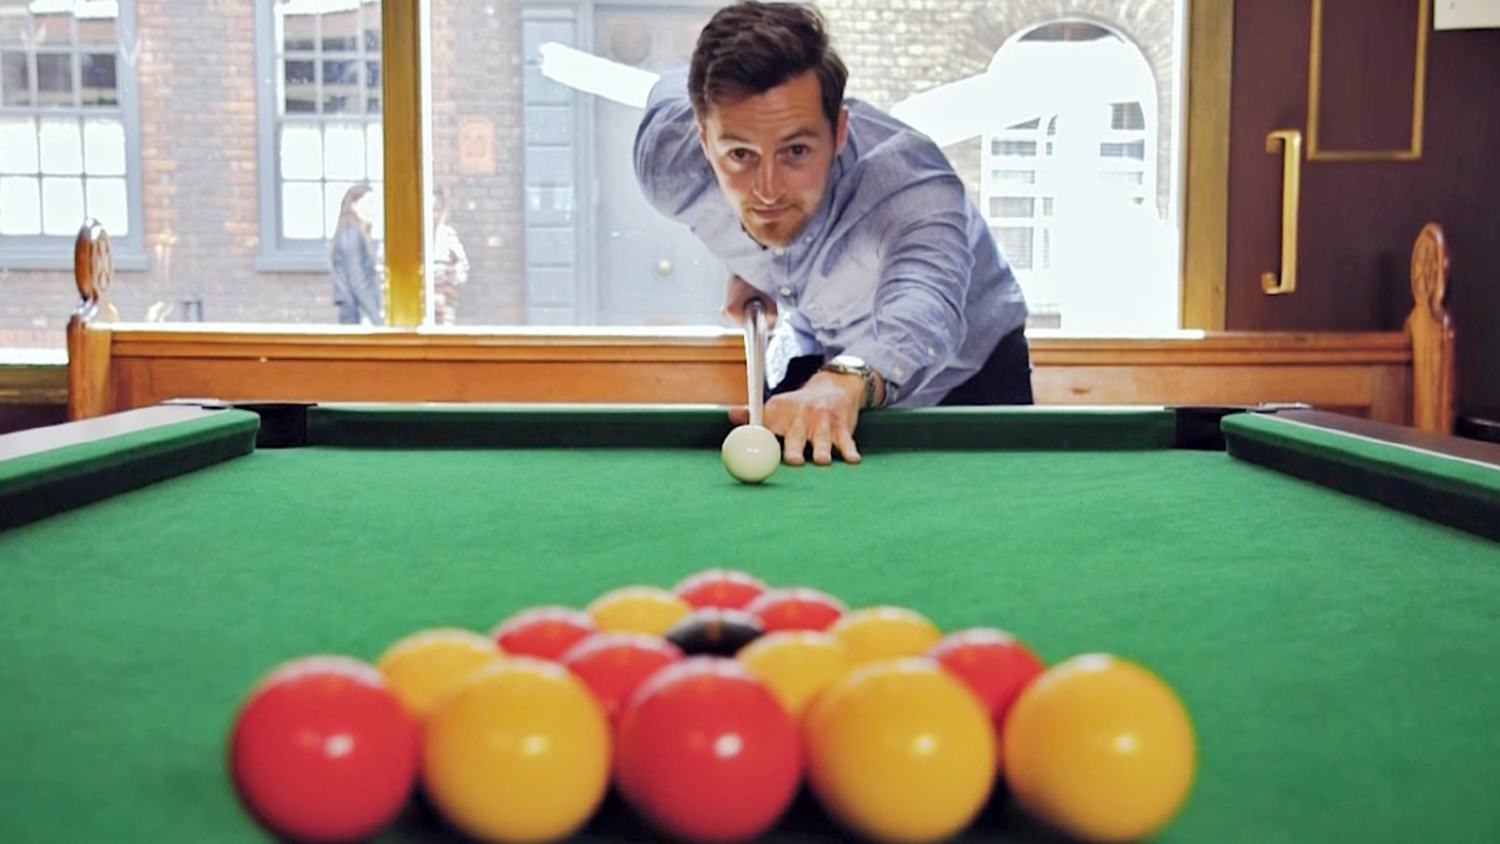Imagine if this image was taken during an important pool tournament. How do you think the setting and the man's focus would change? If this image was taken during an important pool tournament, the setting and the man's focus might change significantly. The pool hall would likely have more spectators around, adding a level of pressure and excitement. This could cause a shift in the man's concentration, making his focus and composure even more critical. The lighting might be more intense, designed to eliminate any shadows on the table for fairness. Additionally, you might see more professional equipment, like tournament-grade pool balls and cues. The atmosphere would be charged with a sense of competition and anticipation, as each shot holds more significant consequences in the context of a tournament. Describe in detail the appearance of the pool table and balls during the tournament. During a tournament, the pool table would be in pristine condition, impeccably clean with perfectly smooth and taut green felt. The rails and edges would be polished and free from any marks or wear. The pool balls themselves would be immaculate, evenly spaced, and brightly colored without any scuffs or scratches. Each ball would reflect the overhead lights, adding a gleaming touch to the visual experience. The cues used by players would be high-quality and meticulously maintained, ensuring precise control over each shot. This immaculate setting would convey a sense of professionalism and add to the intensity of the tournament ambiance. 